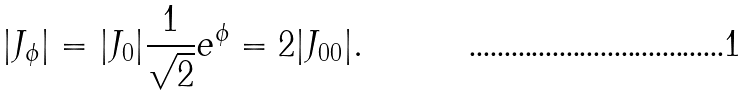Convert formula to latex. <formula><loc_0><loc_0><loc_500><loc_500>| J _ { \phi } | = | J _ { 0 } | \frac { 1 } { \sqrt { 2 } } e ^ { \phi } = 2 | J _ { 0 0 } | .</formula> 